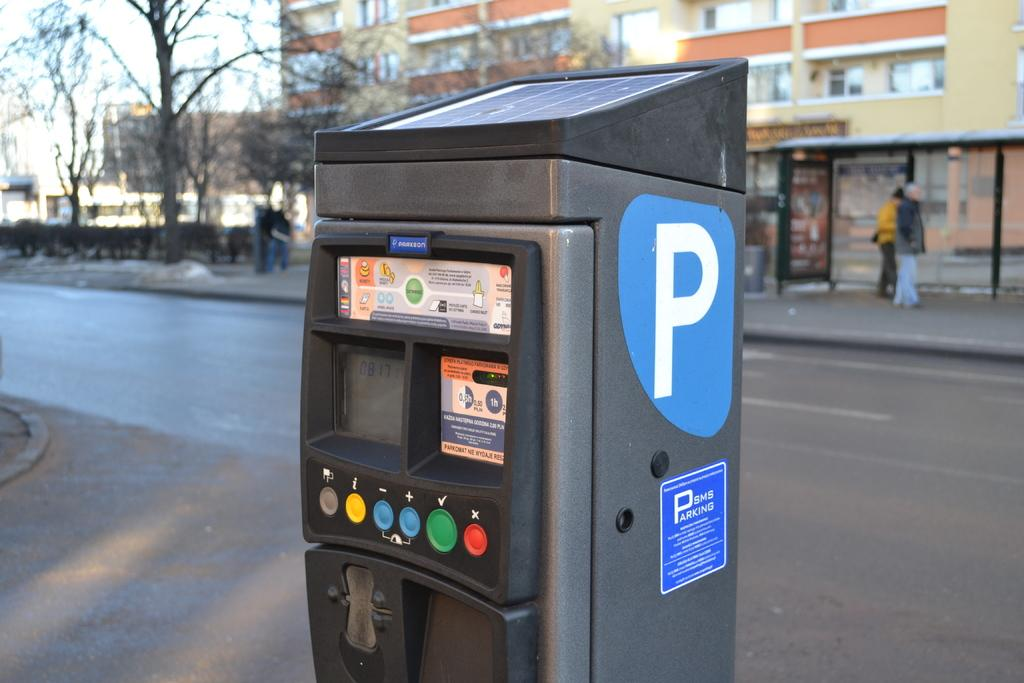<image>
Give a short and clear explanation of the subsequent image. A black machine on the street has a large P on it. 